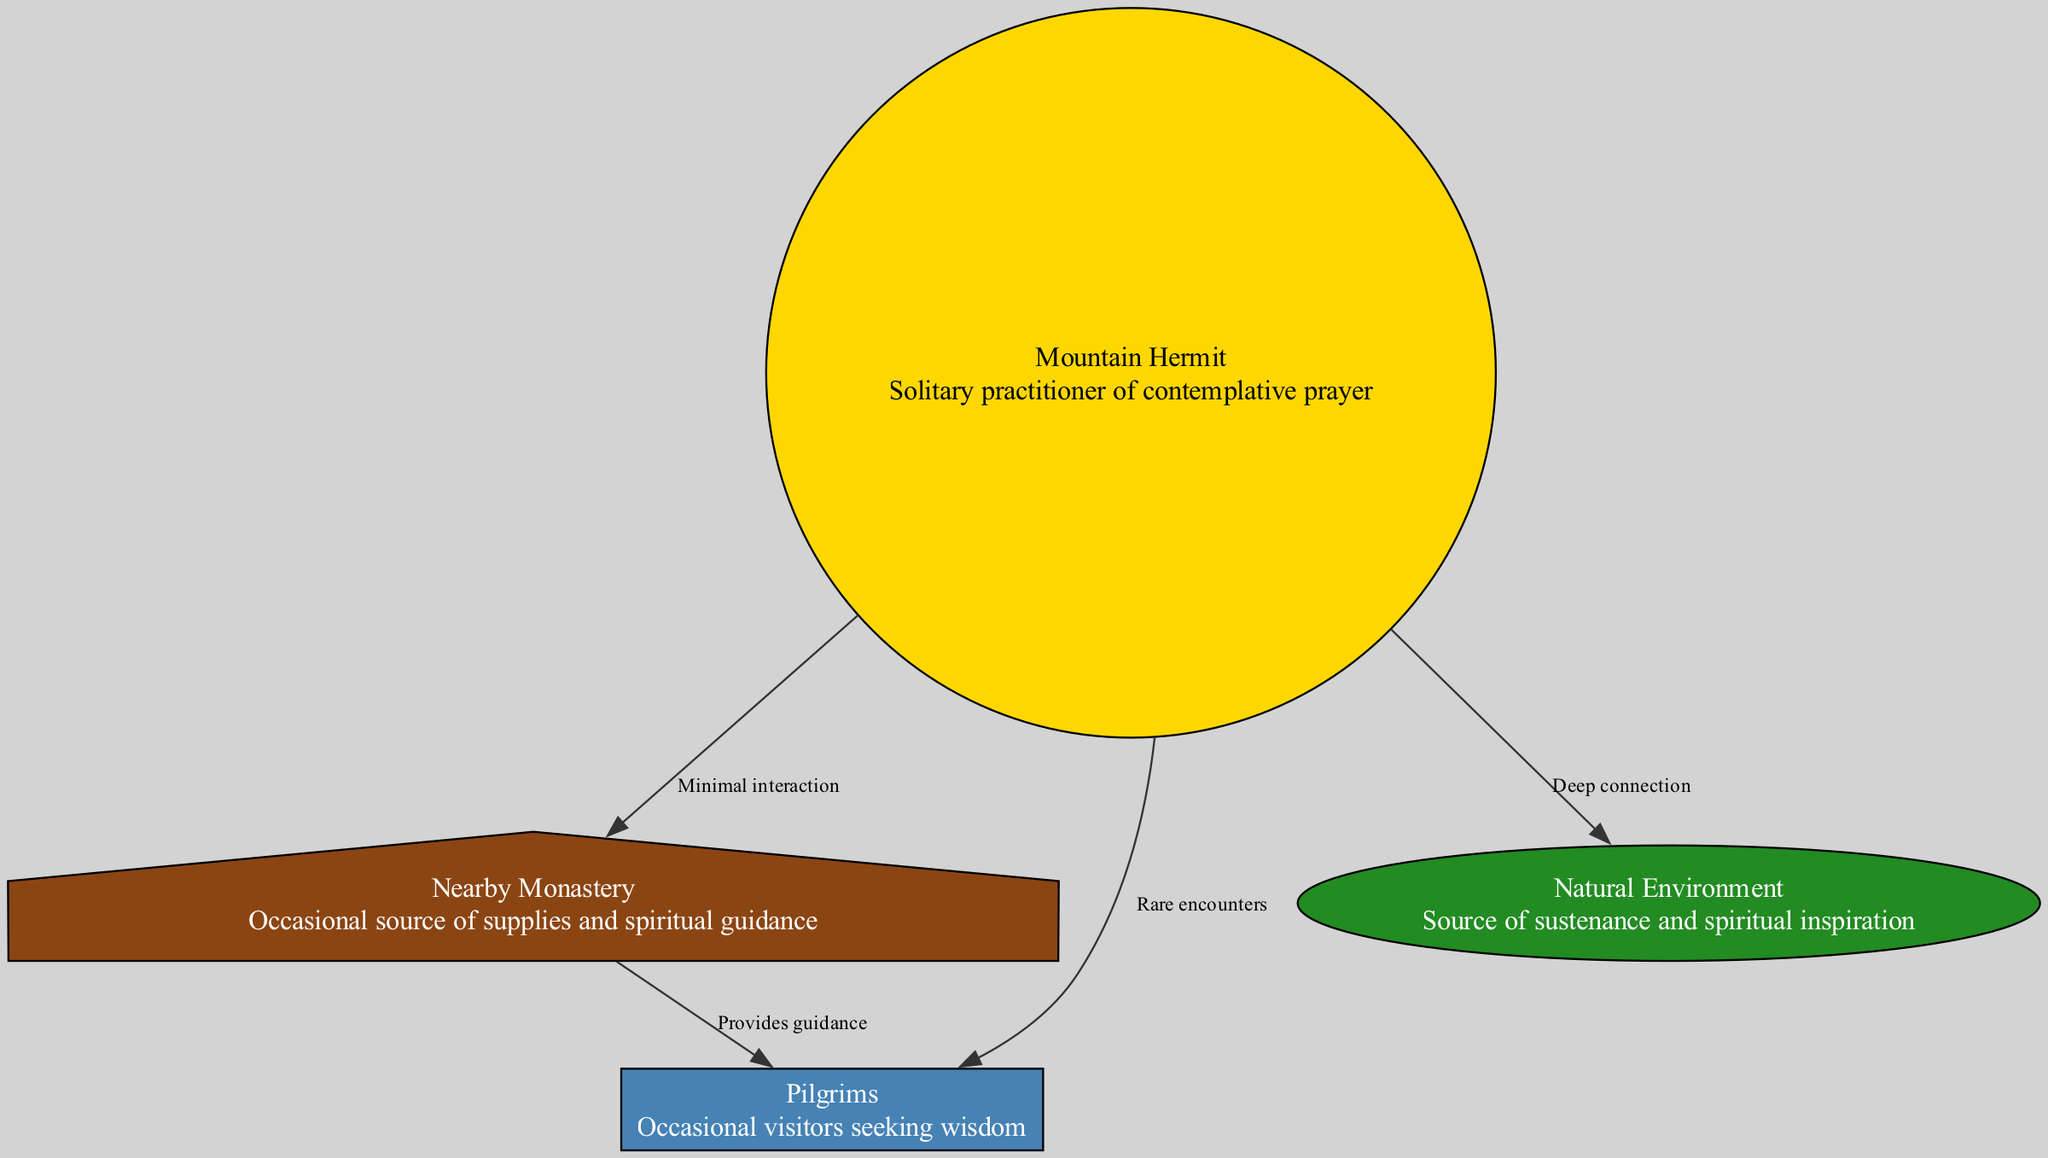What role does the hermit play in the diagram? The hermit is depicted as a solitary practitioner, indicating that their role is focused on individual spiritual practice rather than communal interaction. This information comes from the label and description associated with the hermit node.
Answer: Solitary practitioner How many nodes are present in the diagram? By counting the distinct nodes listed in the data section, we see that there are four nodes: hermit, monastery, pilgrims, and nature. Thus, the total count is determined straightforwardly through enumeration.
Answer: 4 What is the relationship between the hermit and the monastery? The diagram indicates a "Minimal interaction" edge from the hermit node to the monastery node. This can be inferred by examining the edges defined in the data section and identifying the specific connection stated.
Answer: Minimal interaction What type of guidance do the pilgrims receive? The pilgrims receive guidance from the monastery, as indicated by the edge labeled "Provides guidance" that connects the monastery node to the pilgrims node. This relationship is reflected in the edges' descriptions present in the diagram data.
Answer: Guidance What is the nature of the hermit's connection to the natural environment? The connection is described as "Deep connection," which is explicitly stated in the edge that connects the hermit to the nature node. Recognizing this relationship illustrates the significance of nature in the hermit's spiritual practice.
Answer: Deep connection How many edges are connected to the hermit? By examining the edges linked to the hermit node, one can see there are three edges: to the monastery, to the pilgrims, and to nature. Counting these connections provides an answer directly based on the edges listed in the diagram.
Answer: 3 What source of inspiration does the hermit rely on? The hermit relies on the natural environment as a source of sustenance and spiritual inspiration, which is clear from the description stated within the nature node connected to the hermit node. This understanding is derived from the relational context within the diagram.
Answer: Natural Environment What defines the interaction between the monastery and the pilgrims? The relationship is defined by the label "Provides guidance," which indicates that the monastery offers spiritual assistance to the pilgrims. This can be understood through the edge that connects the two nodes as presented in the diagram.
Answer: Provides guidance 